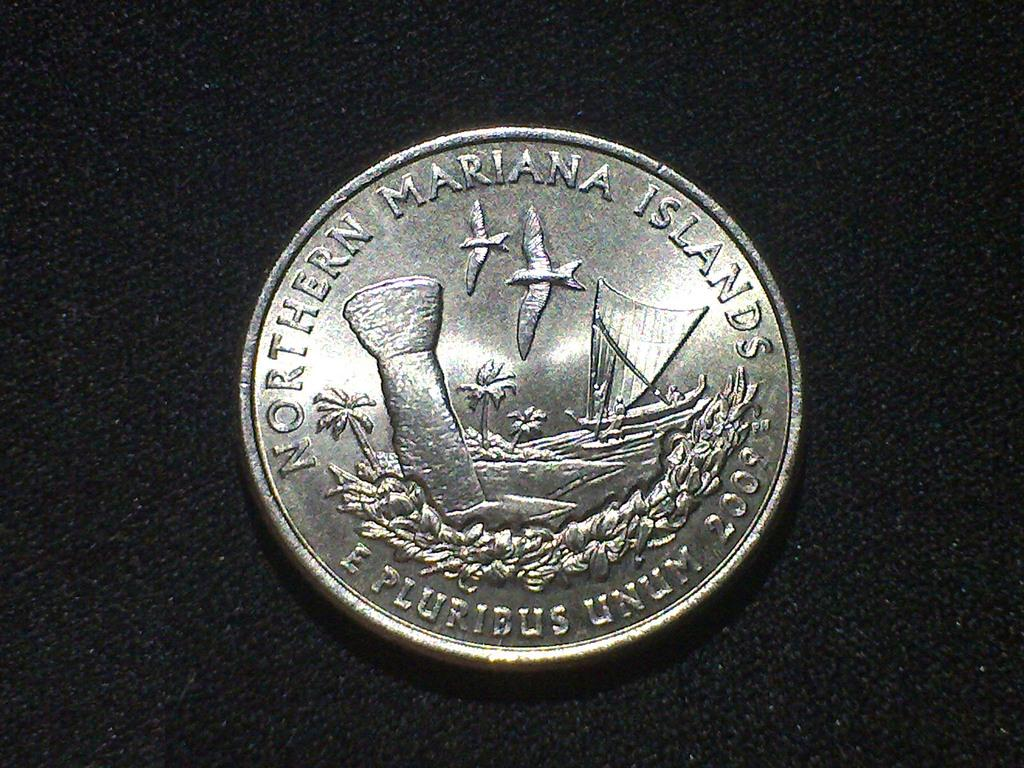<image>
Summarize the visual content of the image. A coin reading "Northern Mariana Islands" on a black surface. 